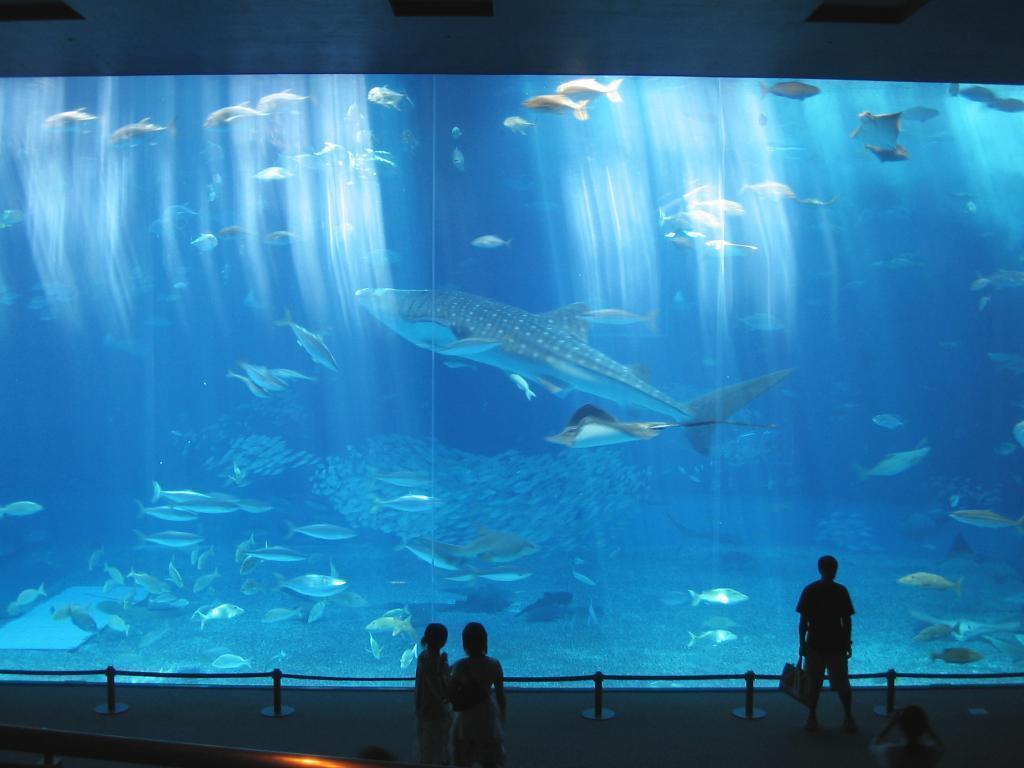Could you give a brief overview of what you see in this image? In this picture we can see a big glass, in it we can see some fishes in a water, side few people are standing and watching. 